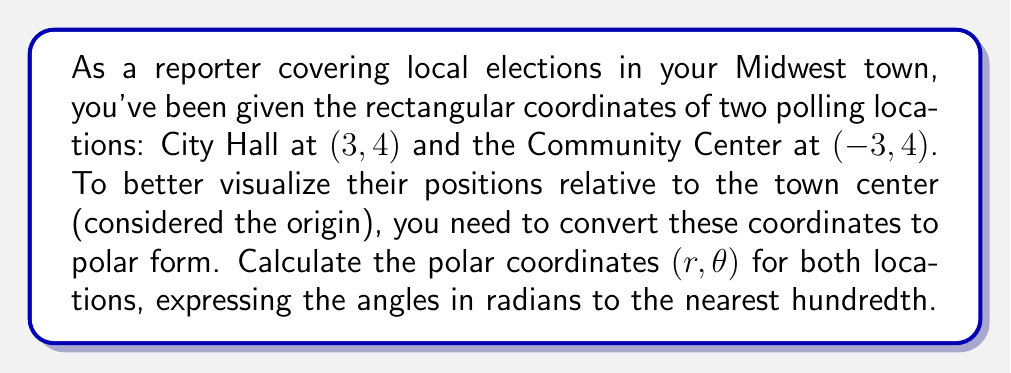Teach me how to tackle this problem. To convert rectangular coordinates $(x, y)$ to polar coordinates $(r, \theta)$, we use the following formulas:

1. $r = \sqrt{x^2 + y^2}$
2. $\theta = \tan^{-1}(\frac{y}{x})$

However, we need to be careful with the arctangent function, as it doesn't always give the correct angle. We must consider the quadrant of the point to determine the correct angle.

For City Hall $(3, 4)$:

1. Calculate $r$:
   $r = \sqrt{3^2 + 4^2} = \sqrt{9 + 16} = \sqrt{25} = 5$

2. Calculate $\theta$:
   $\theta = \tan^{-1}(\frac{4}{3}) \approx 0.9273$ radians
   This is in the first quadrant, so no adjustment is needed.

For Community Center $(-3, 4)$:

1. Calculate $r$:
   $r = \sqrt{(-3)^2 + 4^2} = \sqrt{9 + 16} = \sqrt{25} = 5$

2. Calculate $\theta$:
   $\theta = \tan^{-1}(\frac{4}{-3}) \approx -0.9273$ radians
   However, this point is in the second quadrant, so we need to add $\pi$:
   $\theta = -0.9273 + \pi \approx 2.2143$ radians

[asy]
import geometry;

unitsize(1cm);

draw((-5,0)--(5,0),Arrow);
draw((0,-5)--(0,5),Arrow);

dot((3,4));
dot((-3,4));

label("City Hall (3, 4)", (3,4), E);
label("Community Center (-3, 4)", (-3,4), W);
label("O", (0,0), SW);

draw((0,0)--(3,4),Arrow);
draw((0,0)--(-3,4),Arrow);

[/asy]
Answer: City Hall: $(5, 0.93)$
Community Center: $(5, 2.21)$ 